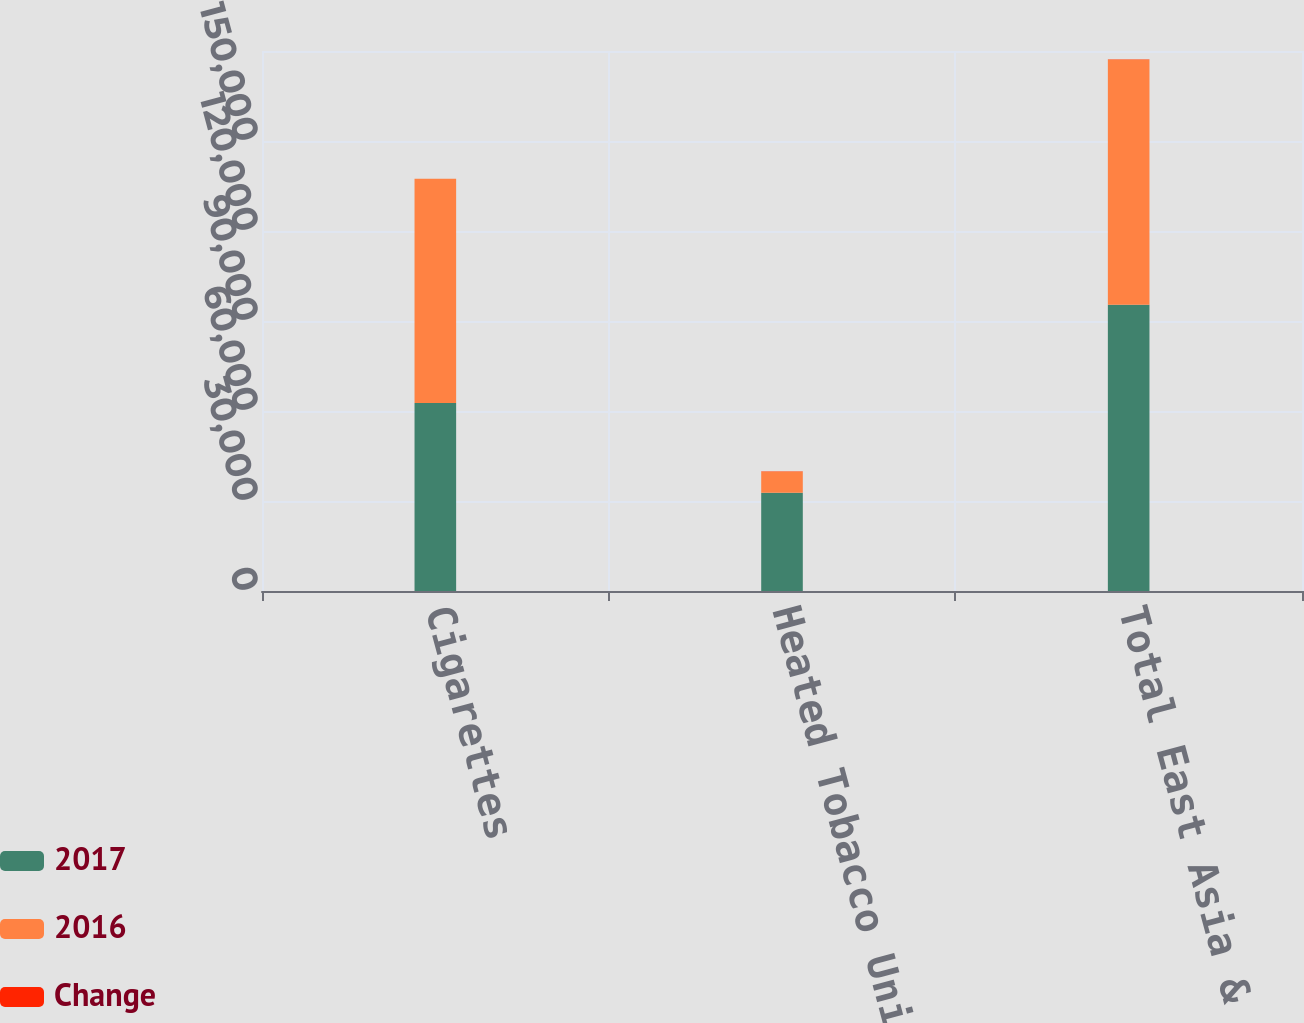Convert chart. <chart><loc_0><loc_0><loc_500><loc_500><stacked_bar_chart><ecel><fcel>Cigarettes<fcel>Heated Tobacco Units<fcel>Total East Asia & Australia<nl><fcel>2017<fcel>62653<fcel>32729<fcel>95382<nl><fcel>2016<fcel>74750<fcel>7070<fcel>81820<nl><fcel>Change<fcel>16.2<fcel>100<fcel>16.6<nl></chart> 